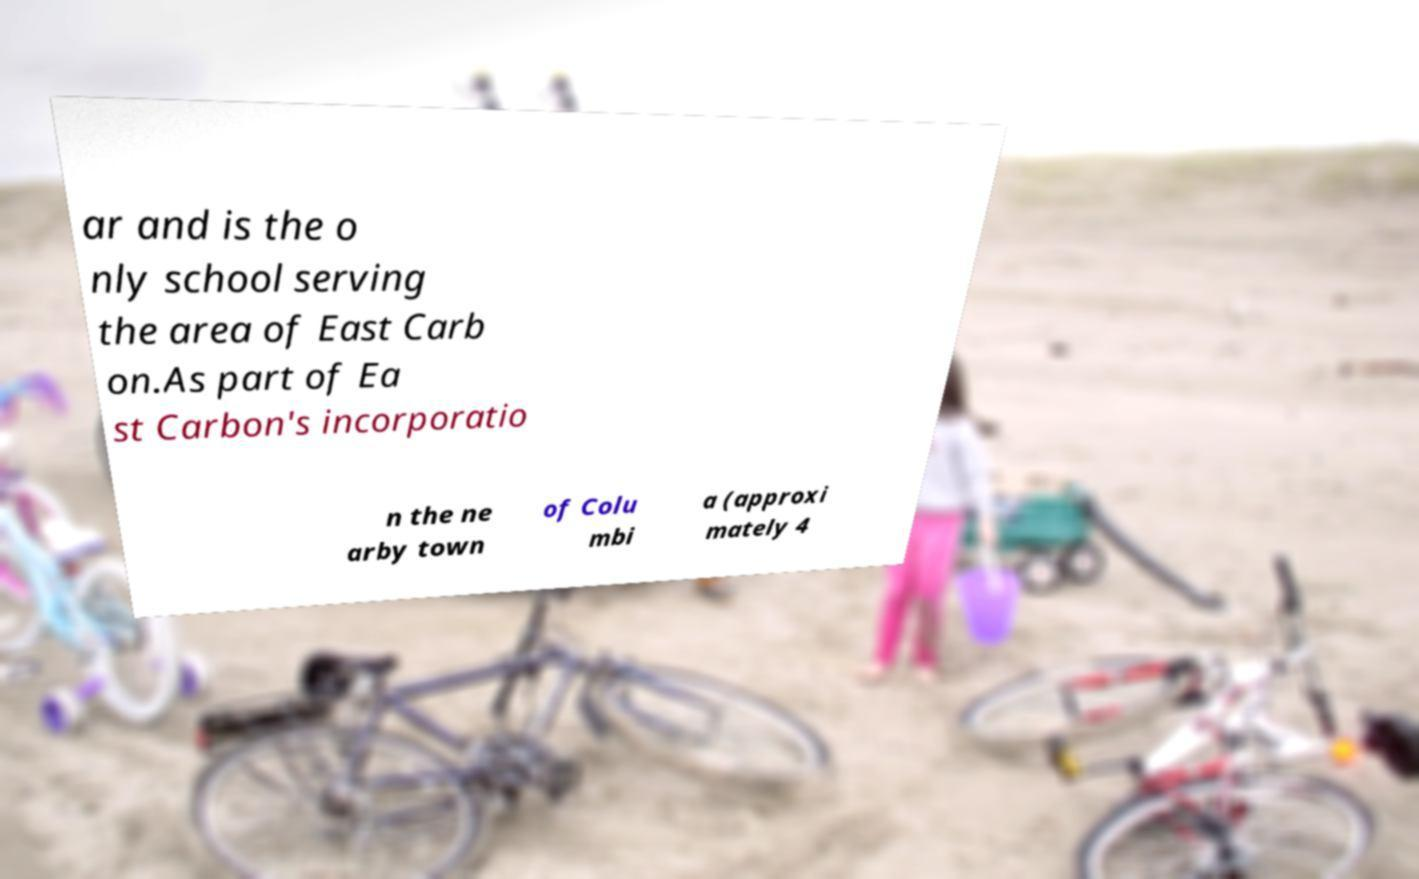What messages or text are displayed in this image? I need them in a readable, typed format. ar and is the o nly school serving the area of East Carb on.As part of Ea st Carbon's incorporatio n the ne arby town of Colu mbi a (approxi mately 4 